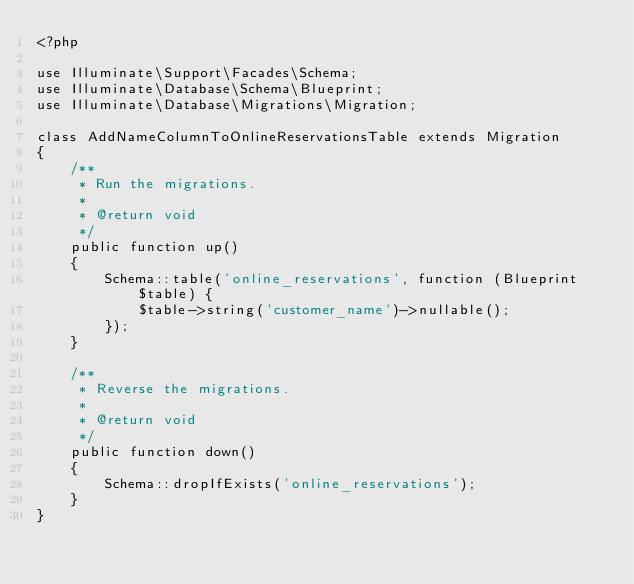Convert code to text. <code><loc_0><loc_0><loc_500><loc_500><_PHP_><?php

use Illuminate\Support\Facades\Schema;
use Illuminate\Database\Schema\Blueprint;
use Illuminate\Database\Migrations\Migration;

class AddNameColumnToOnlineReservationsTable extends Migration
{
    /**
     * Run the migrations.
     *
     * @return void
     */
    public function up()
    {
        Schema::table('online_reservations', function (Blueprint $table) {
            $table->string('customer_name')->nullable();
        });
    }

    /**
     * Reverse the migrations.
     *
     * @return void
     */
    public function down()
    {
        Schema::dropIfExists('online_reservations');
    }
}
</code> 